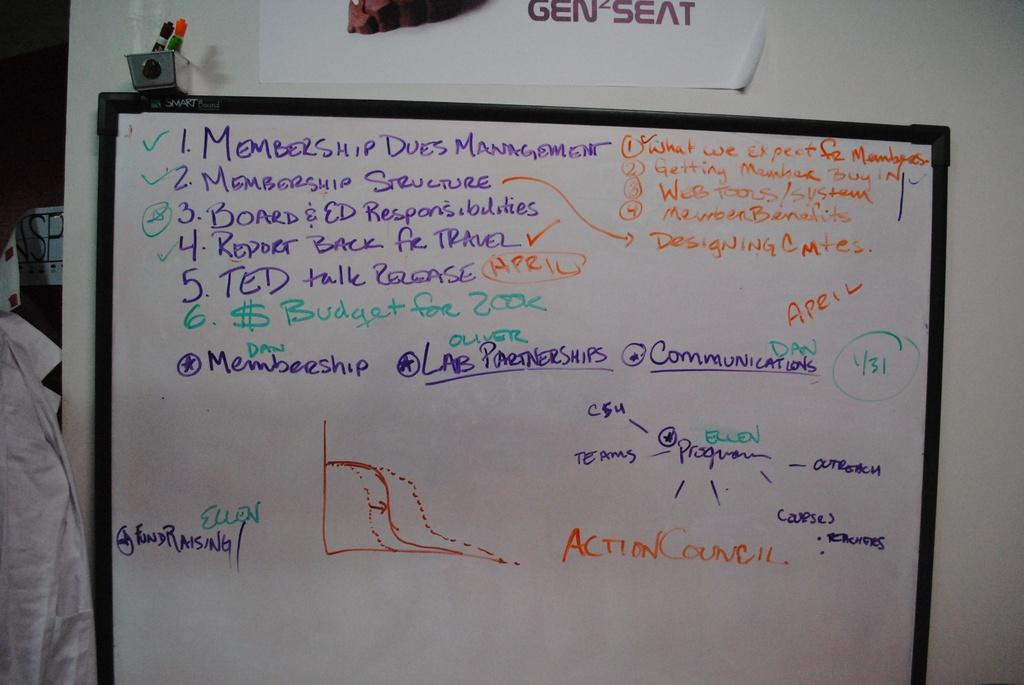Provide a one-sentence caption for the provided image. A person has written about membership dues management on the white board. 